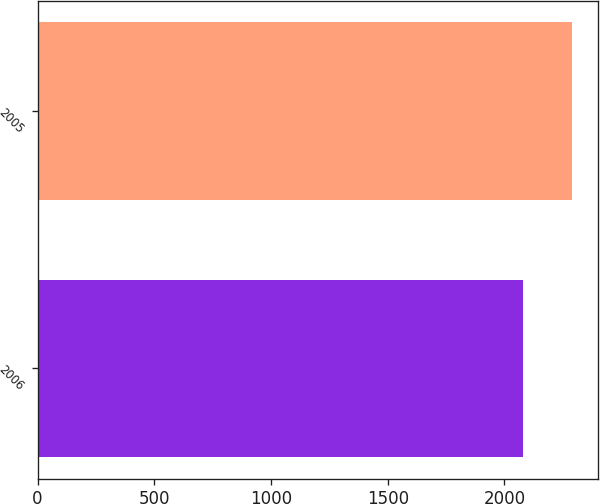Convert chart. <chart><loc_0><loc_0><loc_500><loc_500><bar_chart><fcel>2006<fcel>2005<nl><fcel>2079<fcel>2288.1<nl></chart> 